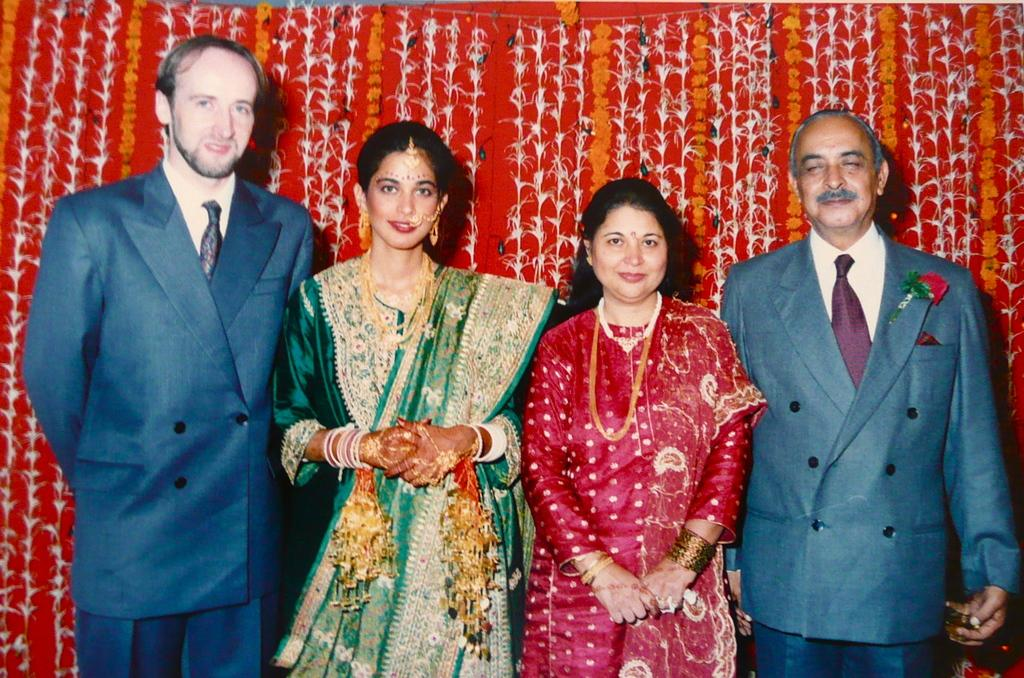What is happening in the image? There are people standing in the image. What can be seen behind the people? There is a background in the image, which includes decoration with flowers. What type of cream is being used to decorate the bushes in the image? There are no bushes or cream present in the image. 